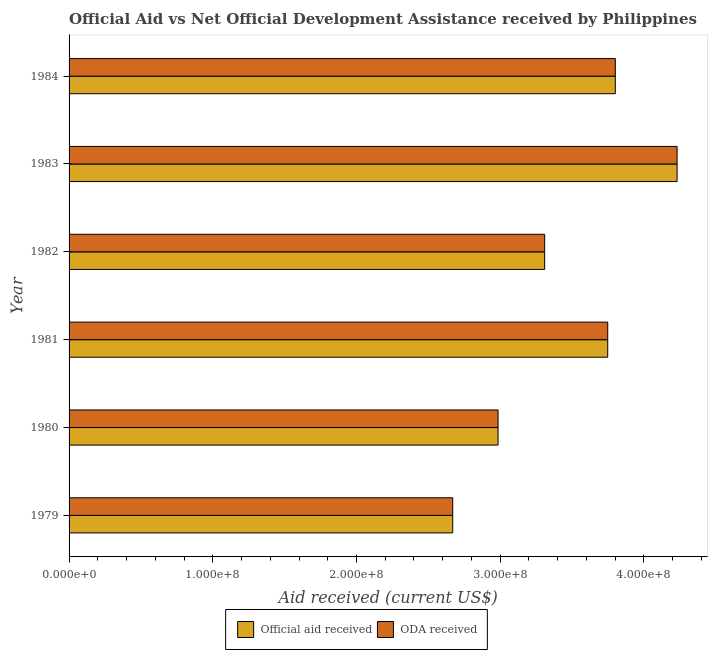Are the number of bars per tick equal to the number of legend labels?
Your answer should be very brief. Yes. How many bars are there on the 1st tick from the top?
Your answer should be compact. 2. What is the official aid received in 1981?
Offer a very short reply. 3.75e+08. Across all years, what is the maximum official aid received?
Make the answer very short. 4.23e+08. Across all years, what is the minimum oda received?
Give a very brief answer. 2.67e+08. In which year was the oda received maximum?
Offer a terse response. 1983. In which year was the oda received minimum?
Offer a terse response. 1979. What is the total oda received in the graph?
Offer a terse response. 2.07e+09. What is the difference between the official aid received in 1983 and that in 1984?
Offer a very short reply. 4.30e+07. What is the difference between the oda received in 1980 and the official aid received in 1982?
Your answer should be very brief. -3.24e+07. What is the average official aid received per year?
Keep it short and to the point. 3.46e+08. In the year 1984, what is the difference between the official aid received and oda received?
Offer a terse response. 0. What is the ratio of the official aid received in 1979 to that in 1982?
Provide a succinct answer. 0.81. Is the official aid received in 1980 less than that in 1982?
Give a very brief answer. Yes. What is the difference between the highest and the second highest official aid received?
Provide a succinct answer. 4.30e+07. What is the difference between the highest and the lowest official aid received?
Provide a short and direct response. 1.56e+08. Is the sum of the official aid received in 1979 and 1984 greater than the maximum oda received across all years?
Your response must be concise. Yes. What does the 1st bar from the top in 1979 represents?
Offer a very short reply. ODA received. What does the 2nd bar from the bottom in 1980 represents?
Make the answer very short. ODA received. How many bars are there?
Provide a succinct answer. 12. Are all the bars in the graph horizontal?
Ensure brevity in your answer.  Yes. Where does the legend appear in the graph?
Keep it short and to the point. Bottom center. How are the legend labels stacked?
Give a very brief answer. Horizontal. What is the title of the graph?
Give a very brief answer. Official Aid vs Net Official Development Assistance received by Philippines . What is the label or title of the X-axis?
Offer a very short reply. Aid received (current US$). What is the Aid received (current US$) in Official aid received in 1979?
Your answer should be very brief. 2.67e+08. What is the Aid received (current US$) in ODA received in 1979?
Offer a very short reply. 2.67e+08. What is the Aid received (current US$) in Official aid received in 1980?
Provide a succinct answer. 2.99e+08. What is the Aid received (current US$) in ODA received in 1980?
Keep it short and to the point. 2.99e+08. What is the Aid received (current US$) in Official aid received in 1981?
Keep it short and to the point. 3.75e+08. What is the Aid received (current US$) of ODA received in 1981?
Give a very brief answer. 3.75e+08. What is the Aid received (current US$) of Official aid received in 1982?
Give a very brief answer. 3.31e+08. What is the Aid received (current US$) in ODA received in 1982?
Provide a short and direct response. 3.31e+08. What is the Aid received (current US$) in Official aid received in 1983?
Offer a terse response. 4.23e+08. What is the Aid received (current US$) of ODA received in 1983?
Ensure brevity in your answer.  4.23e+08. What is the Aid received (current US$) of Official aid received in 1984?
Offer a very short reply. 3.80e+08. What is the Aid received (current US$) in ODA received in 1984?
Offer a very short reply. 3.80e+08. Across all years, what is the maximum Aid received (current US$) in Official aid received?
Your answer should be very brief. 4.23e+08. Across all years, what is the maximum Aid received (current US$) in ODA received?
Keep it short and to the point. 4.23e+08. Across all years, what is the minimum Aid received (current US$) in Official aid received?
Provide a succinct answer. 2.67e+08. Across all years, what is the minimum Aid received (current US$) in ODA received?
Offer a terse response. 2.67e+08. What is the total Aid received (current US$) in Official aid received in the graph?
Keep it short and to the point. 2.07e+09. What is the total Aid received (current US$) in ODA received in the graph?
Keep it short and to the point. 2.07e+09. What is the difference between the Aid received (current US$) of Official aid received in 1979 and that in 1980?
Ensure brevity in your answer.  -3.16e+07. What is the difference between the Aid received (current US$) of ODA received in 1979 and that in 1980?
Your answer should be very brief. -3.16e+07. What is the difference between the Aid received (current US$) of Official aid received in 1979 and that in 1981?
Offer a terse response. -1.08e+08. What is the difference between the Aid received (current US$) in ODA received in 1979 and that in 1981?
Your answer should be compact. -1.08e+08. What is the difference between the Aid received (current US$) in Official aid received in 1979 and that in 1982?
Make the answer very short. -6.40e+07. What is the difference between the Aid received (current US$) of ODA received in 1979 and that in 1982?
Ensure brevity in your answer.  -6.40e+07. What is the difference between the Aid received (current US$) in Official aid received in 1979 and that in 1983?
Your response must be concise. -1.56e+08. What is the difference between the Aid received (current US$) of ODA received in 1979 and that in 1983?
Provide a succinct answer. -1.56e+08. What is the difference between the Aid received (current US$) of Official aid received in 1979 and that in 1984?
Give a very brief answer. -1.13e+08. What is the difference between the Aid received (current US$) in ODA received in 1979 and that in 1984?
Your answer should be compact. -1.13e+08. What is the difference between the Aid received (current US$) in Official aid received in 1980 and that in 1981?
Your response must be concise. -7.63e+07. What is the difference between the Aid received (current US$) of ODA received in 1980 and that in 1981?
Make the answer very short. -7.63e+07. What is the difference between the Aid received (current US$) of Official aid received in 1980 and that in 1982?
Make the answer very short. -3.24e+07. What is the difference between the Aid received (current US$) in ODA received in 1980 and that in 1982?
Provide a short and direct response. -3.24e+07. What is the difference between the Aid received (current US$) of Official aid received in 1980 and that in 1983?
Your answer should be compact. -1.25e+08. What is the difference between the Aid received (current US$) in ODA received in 1980 and that in 1983?
Provide a succinct answer. -1.25e+08. What is the difference between the Aid received (current US$) in Official aid received in 1980 and that in 1984?
Ensure brevity in your answer.  -8.16e+07. What is the difference between the Aid received (current US$) of ODA received in 1980 and that in 1984?
Offer a very short reply. -8.16e+07. What is the difference between the Aid received (current US$) of Official aid received in 1981 and that in 1982?
Provide a succinct answer. 4.39e+07. What is the difference between the Aid received (current US$) of ODA received in 1981 and that in 1982?
Give a very brief answer. 4.39e+07. What is the difference between the Aid received (current US$) of Official aid received in 1981 and that in 1983?
Keep it short and to the point. -4.83e+07. What is the difference between the Aid received (current US$) in ODA received in 1981 and that in 1983?
Offer a terse response. -4.83e+07. What is the difference between the Aid received (current US$) of Official aid received in 1981 and that in 1984?
Your response must be concise. -5.28e+06. What is the difference between the Aid received (current US$) in ODA received in 1981 and that in 1984?
Make the answer very short. -5.28e+06. What is the difference between the Aid received (current US$) of Official aid received in 1982 and that in 1983?
Make the answer very short. -9.22e+07. What is the difference between the Aid received (current US$) in ODA received in 1982 and that in 1983?
Offer a very short reply. -9.22e+07. What is the difference between the Aid received (current US$) of Official aid received in 1982 and that in 1984?
Your answer should be very brief. -4.92e+07. What is the difference between the Aid received (current US$) in ODA received in 1982 and that in 1984?
Your answer should be very brief. -4.92e+07. What is the difference between the Aid received (current US$) of Official aid received in 1983 and that in 1984?
Offer a terse response. 4.30e+07. What is the difference between the Aid received (current US$) of ODA received in 1983 and that in 1984?
Provide a succinct answer. 4.30e+07. What is the difference between the Aid received (current US$) in Official aid received in 1979 and the Aid received (current US$) in ODA received in 1980?
Offer a terse response. -3.16e+07. What is the difference between the Aid received (current US$) in Official aid received in 1979 and the Aid received (current US$) in ODA received in 1981?
Your response must be concise. -1.08e+08. What is the difference between the Aid received (current US$) in Official aid received in 1979 and the Aid received (current US$) in ODA received in 1982?
Provide a short and direct response. -6.40e+07. What is the difference between the Aid received (current US$) of Official aid received in 1979 and the Aid received (current US$) of ODA received in 1983?
Ensure brevity in your answer.  -1.56e+08. What is the difference between the Aid received (current US$) of Official aid received in 1979 and the Aid received (current US$) of ODA received in 1984?
Ensure brevity in your answer.  -1.13e+08. What is the difference between the Aid received (current US$) of Official aid received in 1980 and the Aid received (current US$) of ODA received in 1981?
Your response must be concise. -7.63e+07. What is the difference between the Aid received (current US$) in Official aid received in 1980 and the Aid received (current US$) in ODA received in 1982?
Offer a terse response. -3.24e+07. What is the difference between the Aid received (current US$) in Official aid received in 1980 and the Aid received (current US$) in ODA received in 1983?
Offer a very short reply. -1.25e+08. What is the difference between the Aid received (current US$) in Official aid received in 1980 and the Aid received (current US$) in ODA received in 1984?
Provide a short and direct response. -8.16e+07. What is the difference between the Aid received (current US$) of Official aid received in 1981 and the Aid received (current US$) of ODA received in 1982?
Offer a very short reply. 4.39e+07. What is the difference between the Aid received (current US$) in Official aid received in 1981 and the Aid received (current US$) in ODA received in 1983?
Ensure brevity in your answer.  -4.83e+07. What is the difference between the Aid received (current US$) in Official aid received in 1981 and the Aid received (current US$) in ODA received in 1984?
Make the answer very short. -5.28e+06. What is the difference between the Aid received (current US$) in Official aid received in 1982 and the Aid received (current US$) in ODA received in 1983?
Ensure brevity in your answer.  -9.22e+07. What is the difference between the Aid received (current US$) in Official aid received in 1982 and the Aid received (current US$) in ODA received in 1984?
Make the answer very short. -4.92e+07. What is the difference between the Aid received (current US$) in Official aid received in 1983 and the Aid received (current US$) in ODA received in 1984?
Your response must be concise. 4.30e+07. What is the average Aid received (current US$) of Official aid received per year?
Provide a succinct answer. 3.46e+08. What is the average Aid received (current US$) of ODA received per year?
Provide a short and direct response. 3.46e+08. In the year 1981, what is the difference between the Aid received (current US$) in Official aid received and Aid received (current US$) in ODA received?
Ensure brevity in your answer.  0. In the year 1984, what is the difference between the Aid received (current US$) of Official aid received and Aid received (current US$) of ODA received?
Offer a very short reply. 0. What is the ratio of the Aid received (current US$) in Official aid received in 1979 to that in 1980?
Offer a very short reply. 0.89. What is the ratio of the Aid received (current US$) of ODA received in 1979 to that in 1980?
Make the answer very short. 0.89. What is the ratio of the Aid received (current US$) in Official aid received in 1979 to that in 1981?
Make the answer very short. 0.71. What is the ratio of the Aid received (current US$) of ODA received in 1979 to that in 1981?
Your answer should be compact. 0.71. What is the ratio of the Aid received (current US$) in Official aid received in 1979 to that in 1982?
Give a very brief answer. 0.81. What is the ratio of the Aid received (current US$) of ODA received in 1979 to that in 1982?
Your answer should be very brief. 0.81. What is the ratio of the Aid received (current US$) in Official aid received in 1979 to that in 1983?
Keep it short and to the point. 0.63. What is the ratio of the Aid received (current US$) in ODA received in 1979 to that in 1983?
Offer a terse response. 0.63. What is the ratio of the Aid received (current US$) of Official aid received in 1979 to that in 1984?
Provide a succinct answer. 0.7. What is the ratio of the Aid received (current US$) of ODA received in 1979 to that in 1984?
Make the answer very short. 0.7. What is the ratio of the Aid received (current US$) in Official aid received in 1980 to that in 1981?
Ensure brevity in your answer.  0.8. What is the ratio of the Aid received (current US$) in ODA received in 1980 to that in 1981?
Your answer should be very brief. 0.8. What is the ratio of the Aid received (current US$) of Official aid received in 1980 to that in 1982?
Your answer should be compact. 0.9. What is the ratio of the Aid received (current US$) of ODA received in 1980 to that in 1982?
Your response must be concise. 0.9. What is the ratio of the Aid received (current US$) in Official aid received in 1980 to that in 1983?
Give a very brief answer. 0.71. What is the ratio of the Aid received (current US$) of ODA received in 1980 to that in 1983?
Offer a terse response. 0.71. What is the ratio of the Aid received (current US$) in Official aid received in 1980 to that in 1984?
Ensure brevity in your answer.  0.79. What is the ratio of the Aid received (current US$) of ODA received in 1980 to that in 1984?
Provide a succinct answer. 0.79. What is the ratio of the Aid received (current US$) of Official aid received in 1981 to that in 1982?
Provide a succinct answer. 1.13. What is the ratio of the Aid received (current US$) of ODA received in 1981 to that in 1982?
Offer a terse response. 1.13. What is the ratio of the Aid received (current US$) of Official aid received in 1981 to that in 1983?
Provide a succinct answer. 0.89. What is the ratio of the Aid received (current US$) of ODA received in 1981 to that in 1983?
Make the answer very short. 0.89. What is the ratio of the Aid received (current US$) in Official aid received in 1981 to that in 1984?
Give a very brief answer. 0.99. What is the ratio of the Aid received (current US$) of ODA received in 1981 to that in 1984?
Your answer should be compact. 0.99. What is the ratio of the Aid received (current US$) in Official aid received in 1982 to that in 1983?
Make the answer very short. 0.78. What is the ratio of the Aid received (current US$) of ODA received in 1982 to that in 1983?
Offer a very short reply. 0.78. What is the ratio of the Aid received (current US$) in Official aid received in 1982 to that in 1984?
Offer a terse response. 0.87. What is the ratio of the Aid received (current US$) of ODA received in 1982 to that in 1984?
Make the answer very short. 0.87. What is the ratio of the Aid received (current US$) in Official aid received in 1983 to that in 1984?
Keep it short and to the point. 1.11. What is the ratio of the Aid received (current US$) of ODA received in 1983 to that in 1984?
Offer a terse response. 1.11. What is the difference between the highest and the second highest Aid received (current US$) of Official aid received?
Provide a short and direct response. 4.30e+07. What is the difference between the highest and the second highest Aid received (current US$) of ODA received?
Make the answer very short. 4.30e+07. What is the difference between the highest and the lowest Aid received (current US$) of Official aid received?
Your answer should be very brief. 1.56e+08. What is the difference between the highest and the lowest Aid received (current US$) of ODA received?
Your response must be concise. 1.56e+08. 